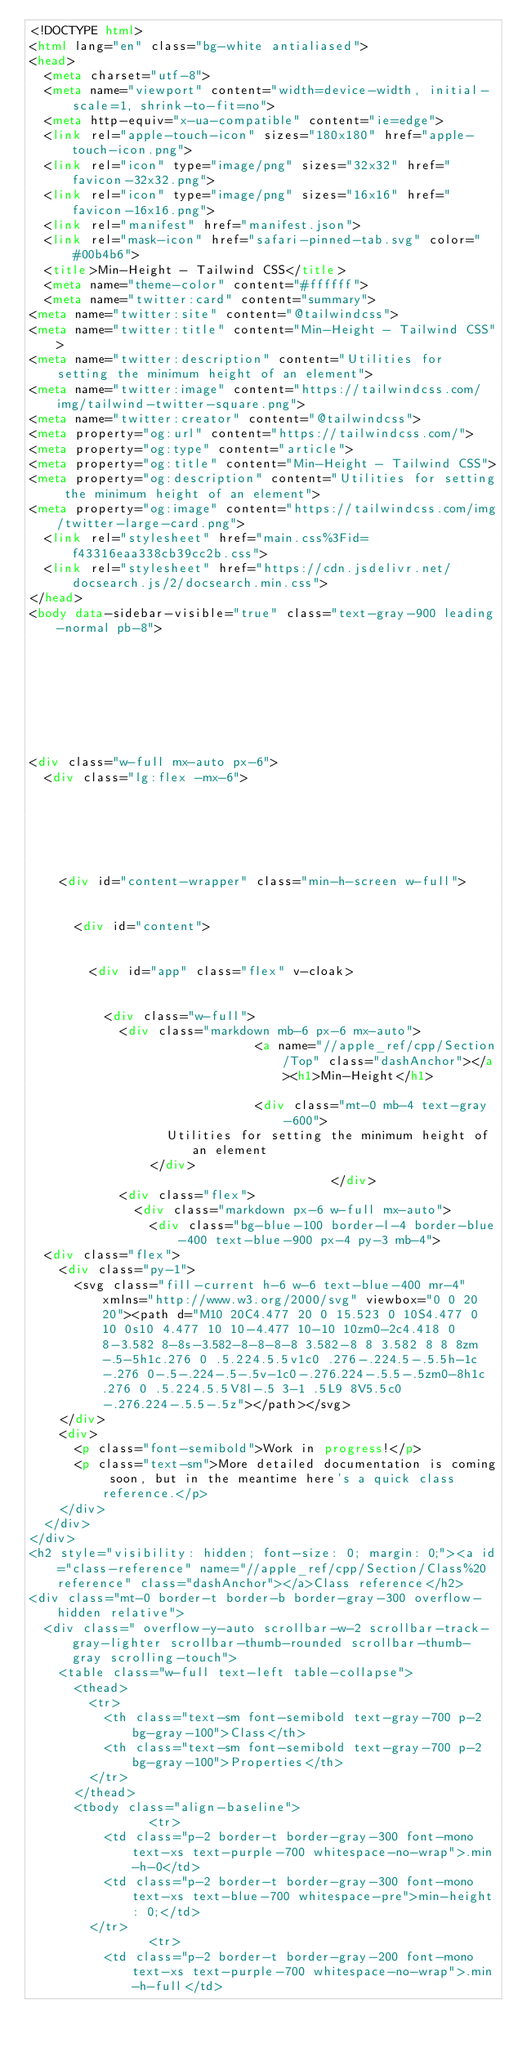<code> <loc_0><loc_0><loc_500><loc_500><_HTML_><!DOCTYPE html>
<html lang="en" class="bg-white antialiased">
<head>
  <meta charset="utf-8">
  <meta name="viewport" content="width=device-width, initial-scale=1, shrink-to-fit=no">
  <meta http-equiv="x-ua-compatible" content="ie=edge">
  <link rel="apple-touch-icon" sizes="180x180" href="apple-touch-icon.png">
  <link rel="icon" type="image/png" sizes="32x32" href="favicon-32x32.png">
  <link rel="icon" type="image/png" sizes="16x16" href="favicon-16x16.png">
  <link rel="manifest" href="manifest.json">
  <link rel="mask-icon" href="safari-pinned-tab.svg" color="#00b4b6">
  <title>Min-Height - Tailwind CSS</title>
  <meta name="theme-color" content="#ffffff">
  <meta name="twitter:card" content="summary">
<meta name="twitter:site" content="@tailwindcss">
<meta name="twitter:title" content="Min-Height - Tailwind CSS">
<meta name="twitter:description" content="Utilities for setting the minimum height of an element">
<meta name="twitter:image" content="https://tailwindcss.com/img/tailwind-twitter-square.png">
<meta name="twitter:creator" content="@tailwindcss">
<meta property="og:url" content="https://tailwindcss.com/">
<meta property="og:type" content="article">
<meta property="og:title" content="Min-Height - Tailwind CSS">
<meta property="og:description" content="Utilities for setting the minimum height of an element">
<meta property="og:image" content="https://tailwindcss.com/img/twitter-large-card.png">
  <link rel="stylesheet" href="main.css%3Fid=f43316eaa338cb39cc2b.css">
  <link rel="stylesheet" href="https://cdn.jsdelivr.net/docsearch.js/2/docsearch.min.css">
</head>
<body data-sidebar-visible="true" class="text-gray-900 leading-normal pb-8">








<div class="w-full mx-auto px-6">
  <div class="lg:flex -mx-6">

    
    
    

    
    <div id="content-wrapper" class="min-h-screen w-full">

      
      <div id="content">

        
        <div id="app" class="flex" v-cloak>

          
          <div class="w-full">
            <div class="markdown mb-6 px-6 mx-auto">
                              <a name="//apple_ref/cpp/Section/Top" class="dashAnchor"></a><h1>Min-Height</h1>
              
                              <div class="mt-0 mb-4 text-gray-600">
                  Utilities for setting the minimum height of an element
                </div>
                                        </div>
            <div class="flex">
              <div class="markdown px-6 w-full mx-auto">
                <div class="bg-blue-100 border-l-4 border-blue-400 text-blue-900 px-4 py-3 mb-4">
  <div class="flex">
    <div class="py-1">
      <svg class="fill-current h-6 w-6 text-blue-400 mr-4" xmlns="http://www.w3.org/2000/svg" viewbox="0 0 20 20"><path d="M10 20C4.477 20 0 15.523 0 10S4.477 0 10 0s10 4.477 10 10-4.477 10-10 10zm0-2c4.418 0 8-3.582 8-8s-3.582-8-8-8-8 3.582-8 8 3.582 8 8 8zm-.5-5h1c.276 0 .5.224.5.5v1c0 .276-.224.5-.5.5h-1c-.276 0-.5-.224-.5-.5v-1c0-.276.224-.5.5-.5zm0-8h1c.276 0 .5.224.5.5V8l-.5 3-1 .5L9 8V5.5c0-.276.224-.5.5-.5z"></path></svg>
    </div>
    <div>
      <p class="font-semibold">Work in progress!</p>
      <p class="text-sm">More detailed documentation is coming soon, but in the meantime here's a quick class reference.</p>
    </div>
  </div>
</div>
<h2 style="visibility: hidden; font-size: 0; margin: 0;"><a id="class-reference" name="//apple_ref/cpp/Section/Class%20reference" class="dashAnchor"></a>Class reference</h2>
<div class="mt-0 border-t border-b border-gray-300 overflow-hidden relative">
  <div class=" overflow-y-auto scrollbar-w-2 scrollbar-track-gray-lighter scrollbar-thumb-rounded scrollbar-thumb-gray scrolling-touch">
    <table class="w-full text-left table-collapse">
      <thead>
        <tr>
          <th class="text-sm font-semibold text-gray-700 p-2 bg-gray-100">Class</th>
          <th class="text-sm font-semibold text-gray-700 p-2 bg-gray-100">Properties</th>
        </tr>
      </thead>
      <tbody class="align-baseline">
                <tr>
          <td class="p-2 border-t border-gray-300 font-mono text-xs text-purple-700 whitespace-no-wrap">.min-h-0</td>
          <td class="p-2 border-t border-gray-300 font-mono text-xs text-blue-700 whitespace-pre">min-height: 0;</td>
        </tr>
                <tr>
          <td class="p-2 border-t border-gray-200 font-mono text-xs text-purple-700 whitespace-no-wrap">.min-h-full</td></code> 